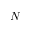<formula> <loc_0><loc_0><loc_500><loc_500>N</formula> 